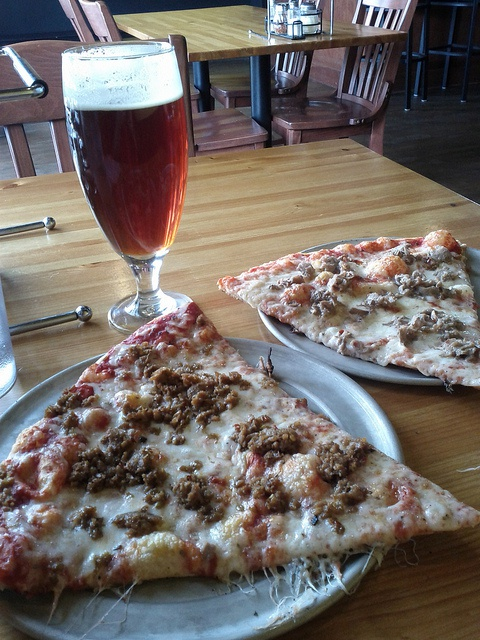Describe the objects in this image and their specific colors. I can see pizza in navy, gray, darkgray, black, and maroon tones, dining table in navy, tan, black, and gray tones, wine glass in navy, white, black, maroon, and darkgray tones, pizza in navy, darkgray, gray, and lightgray tones, and chair in navy, gray, darkgray, and white tones in this image. 